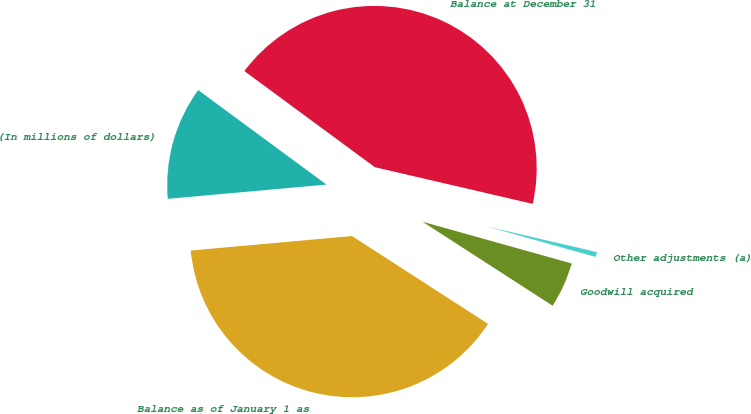<chart> <loc_0><loc_0><loc_500><loc_500><pie_chart><fcel>(In millions of dollars)<fcel>Balance as of January 1 as<fcel>Goodwill acquired<fcel>Other adjustments (a)<fcel>Balance at December 31<nl><fcel>11.53%<fcel>39.45%<fcel>4.78%<fcel>0.71%<fcel>43.53%<nl></chart> 